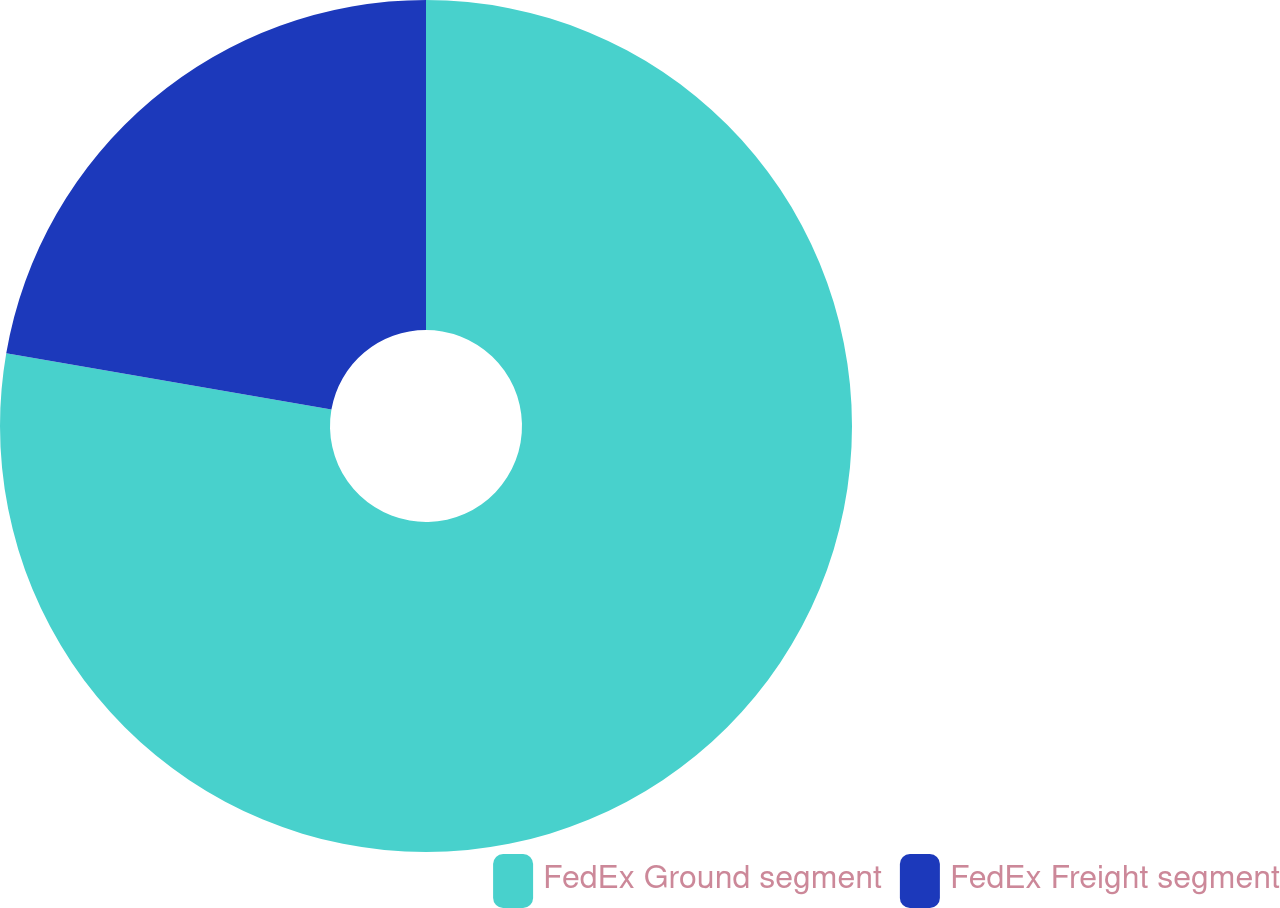Convert chart. <chart><loc_0><loc_0><loc_500><loc_500><pie_chart><fcel>FedEx Ground segment<fcel>FedEx Freight segment<nl><fcel>77.73%<fcel>22.27%<nl></chart> 